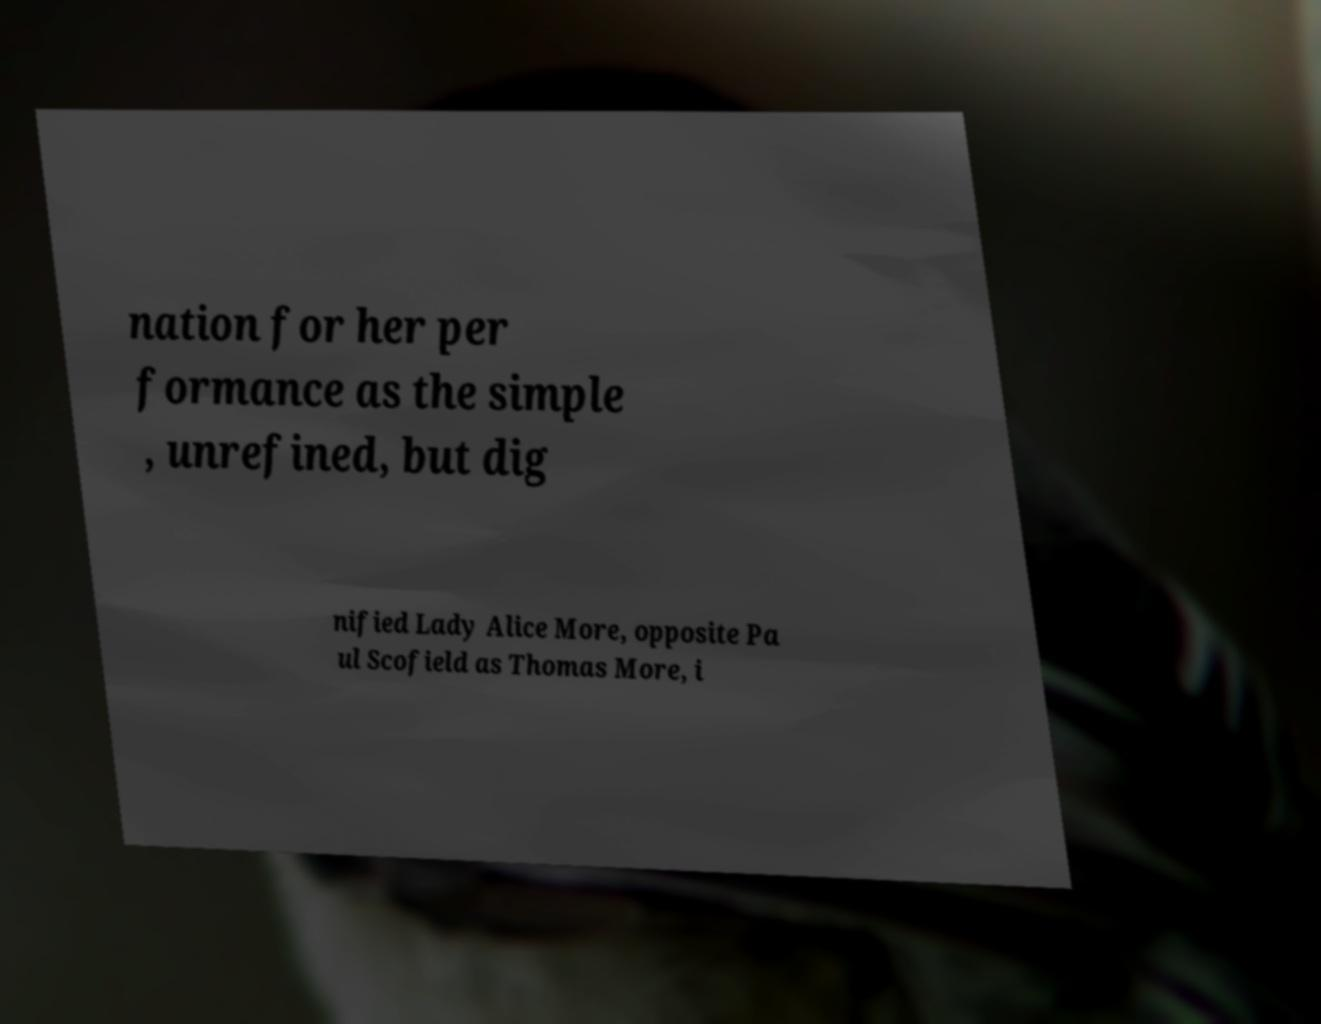Can you read and provide the text displayed in the image?This photo seems to have some interesting text. Can you extract and type it out for me? nation for her per formance as the simple , unrefined, but dig nified Lady Alice More, opposite Pa ul Scofield as Thomas More, i 